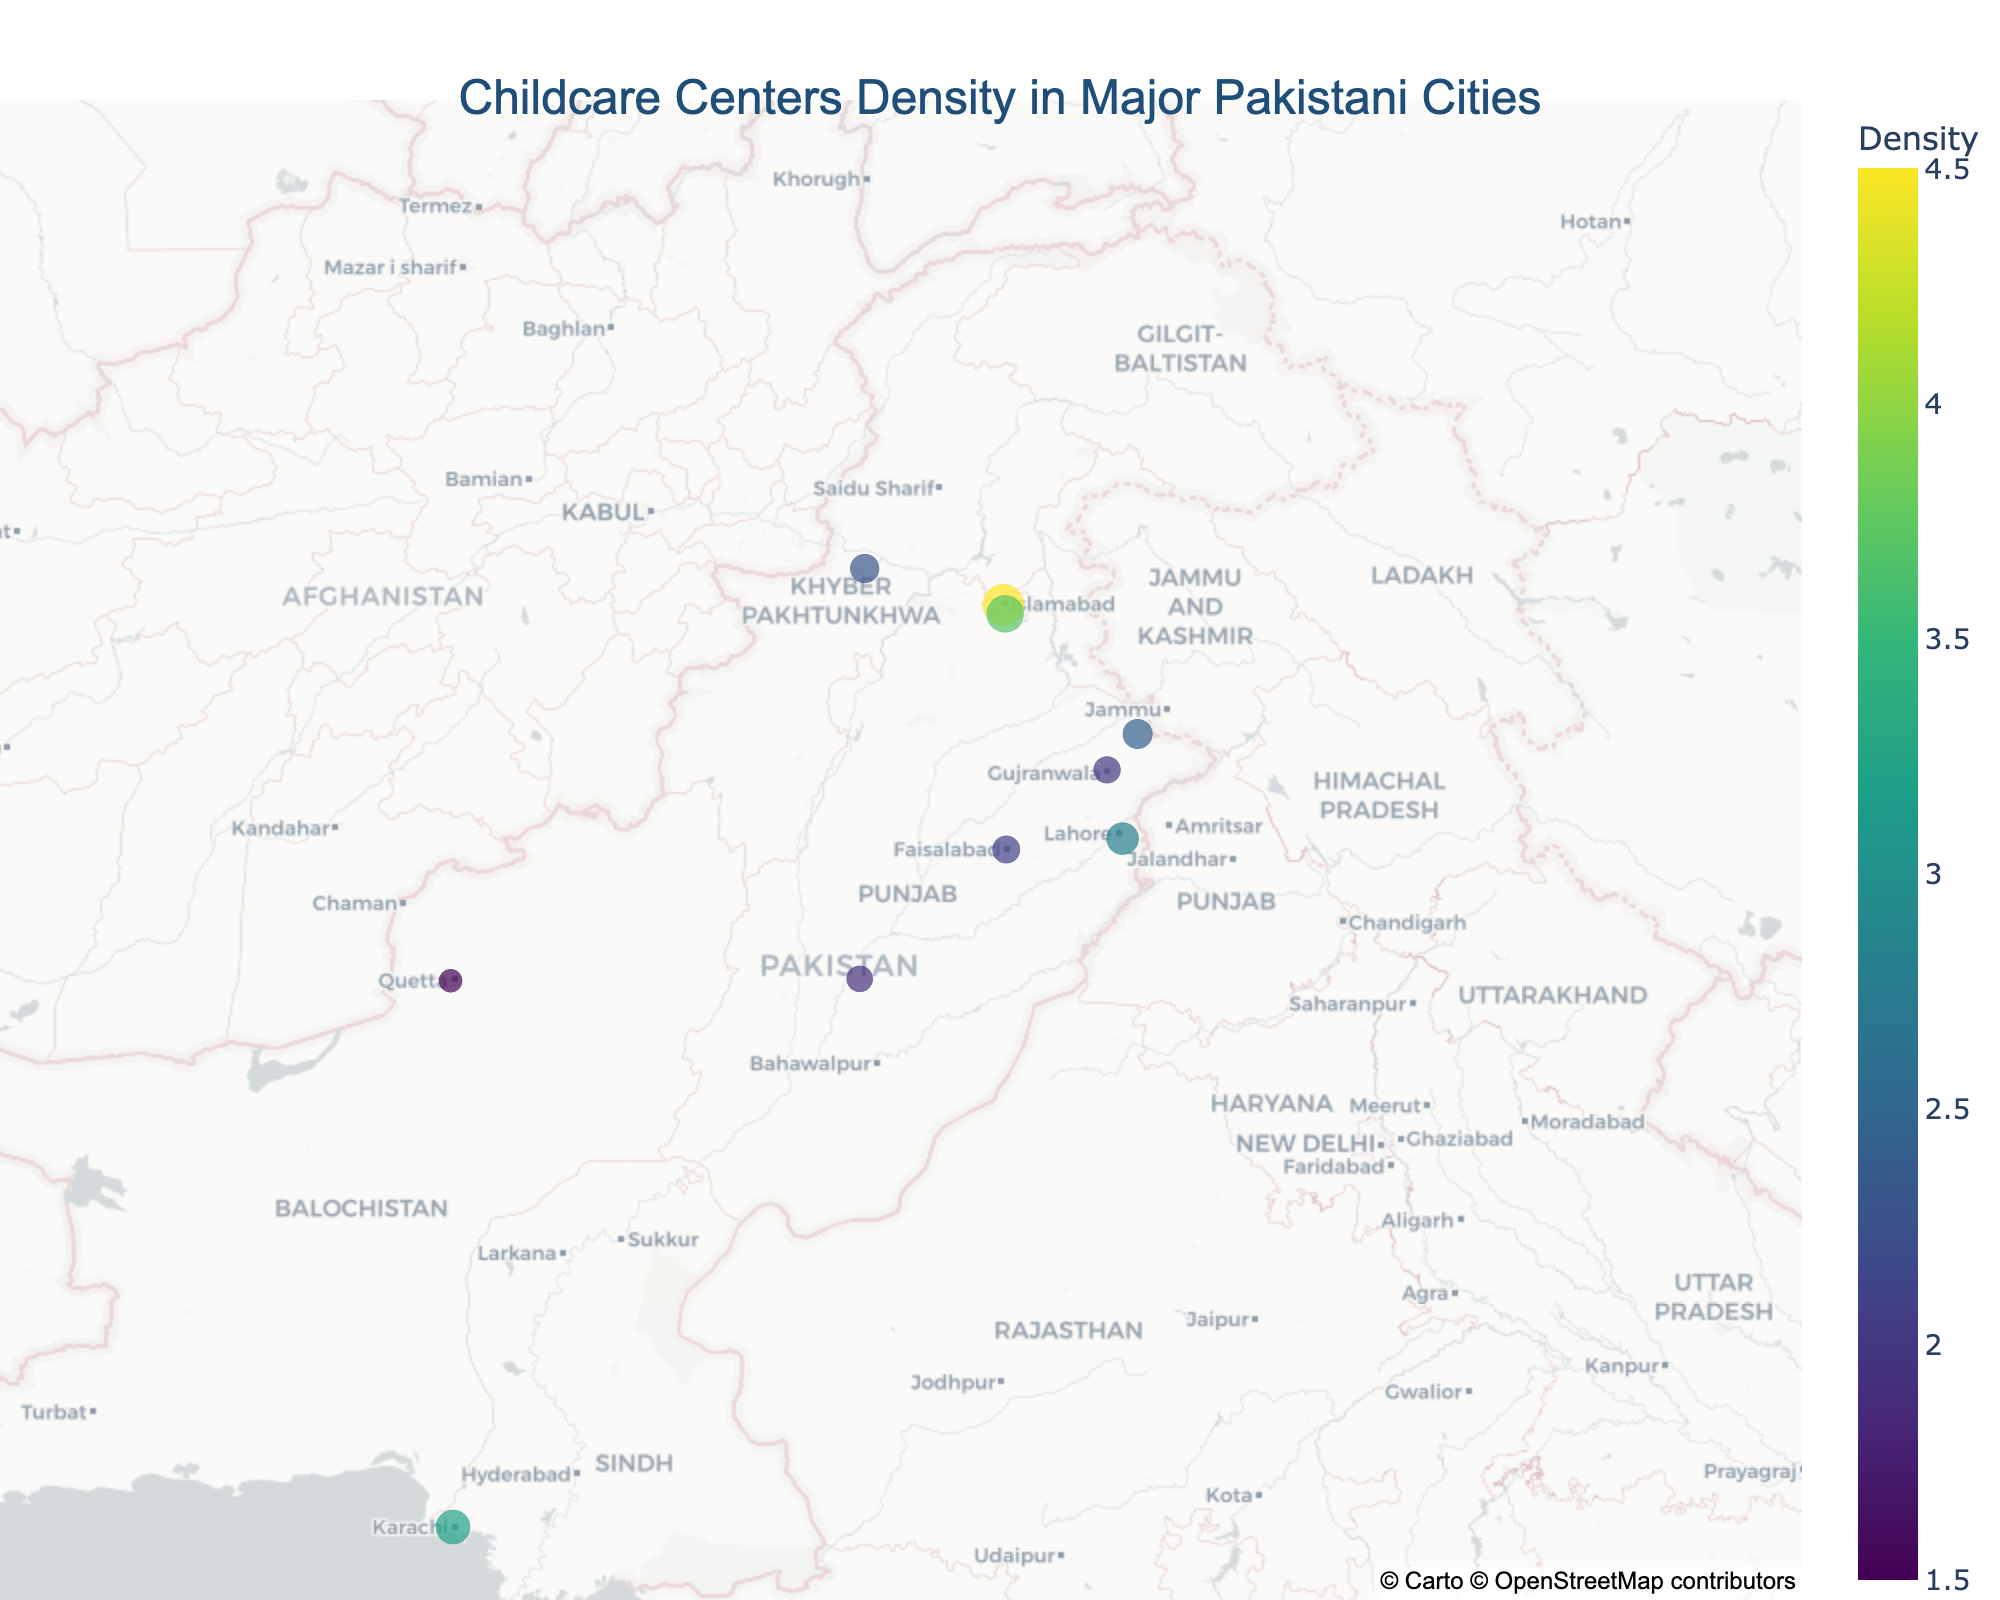Which city has the highest density of childcare centers? By looking at the color scales and the size of the markers, Islamabad has the largest marker and a darker color representing the highest density of 4.5.
Answer: Islamabad How many cities are represented in the plot? Each city is represented by a marker, and counting the total markers gives us the number of cities.
Answer: 10 Which city has the lowest density of childcare centers? The smallest marker with the lightest color represents the lowest density, which corresponds to Quetta with a density of 1.5.
Answer: Quetta Which cities have a density of childcare centers greater than 3.0? Looking at the size and color of the markers, Karachi, Islamabad, and Rawalpindi have densities greater than 3.0.
Answer: Karachi, Islamabad, Rawalpindi What is the average density of childcare centers in the plotted cities? Summing up the densities of all cities (3.2 + 2.8 + 4.5 + 3.7 + 2.1 + 1.9 + 2.3 + 1.5 + 2.0 + 2.4) = 26.4, and dividing by the number of cities (10), we get 26.4 / 10 = 2.64.
Answer: 2.64 Which city has a childcare center density closest to the median value of all cities? First, we arrange the densities in ascending order (1.5, 1.9, 2.0, 2.1, 2.3, 2.4, 2.8, 3.2, 3.7, 4.5). The median is the average of the 5th and 6th values, which is (2.3 + 2.4) / 2 = 2.35. Peshawar, with a density of 2.3, is closest to this median.
Answer: Peshawar Is Karachi's childcare center density higher than Lahore's? Comparing the densities of Karachi (3.2) and Lahore (2.8), Karachi's density is higher.
Answer: Yes What is the difference in childcare center density between the city with the highest density and the city with the lowest density? The highest density is in Islamabad (4.5), and the lowest is in Quetta (1.5). The difference is 4.5 - 1.5 = 3.0.
Answer: 3.0 Which city in the Punjab region has the highest density of childcare centers? Looking at the cities in Punjab (Lahore, Faisalabad, Multan, Gujranwala, Sialkot), Lahore has the highest density of 2.8.
Answer: Lahore 